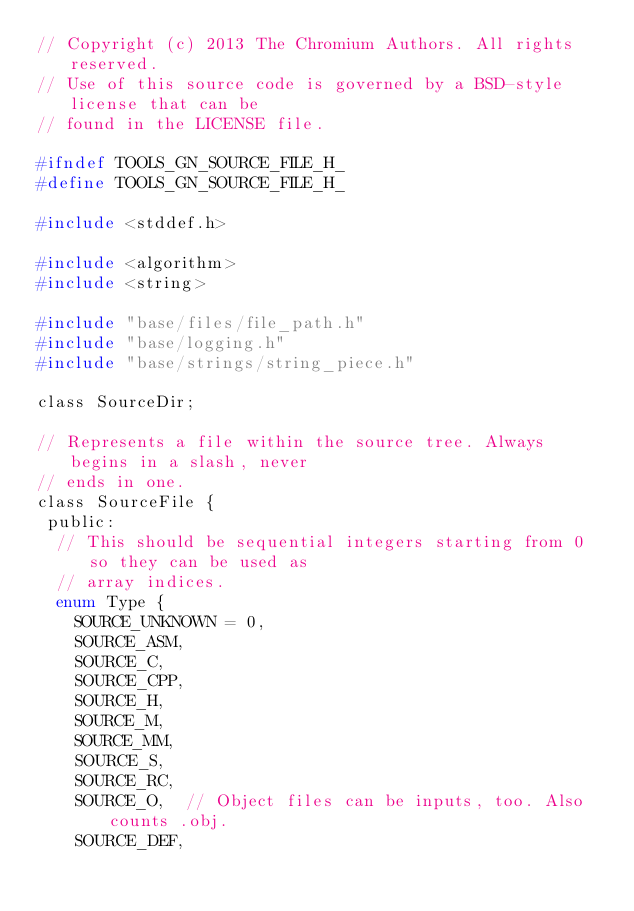Convert code to text. <code><loc_0><loc_0><loc_500><loc_500><_C_>// Copyright (c) 2013 The Chromium Authors. All rights reserved.
// Use of this source code is governed by a BSD-style license that can be
// found in the LICENSE file.

#ifndef TOOLS_GN_SOURCE_FILE_H_
#define TOOLS_GN_SOURCE_FILE_H_

#include <stddef.h>

#include <algorithm>
#include <string>

#include "base/files/file_path.h"
#include "base/logging.h"
#include "base/strings/string_piece.h"

class SourceDir;

// Represents a file within the source tree. Always begins in a slash, never
// ends in one.
class SourceFile {
 public:
  // This should be sequential integers starting from 0 so they can be used as
  // array indices.
  enum Type {
    SOURCE_UNKNOWN = 0,
    SOURCE_ASM,
    SOURCE_C,
    SOURCE_CPP,
    SOURCE_H,
    SOURCE_M,
    SOURCE_MM,
    SOURCE_S,
    SOURCE_RC,
    SOURCE_O,  // Object files can be inputs, too. Also counts .obj.
    SOURCE_DEF,
</code> 